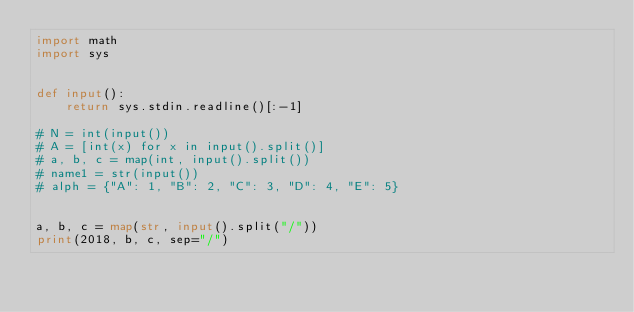Convert code to text. <code><loc_0><loc_0><loc_500><loc_500><_Python_>import math
import sys


def input():
    return sys.stdin.readline()[:-1]

# N = int(input())
# A = [int(x) for x in input().split()]
# a, b, c = map(int, input().split())
# name1 = str(input())
# alph = {"A": 1, "B": 2, "C": 3, "D": 4, "E": 5}


a, b, c = map(str, input().split("/"))
print(2018, b, c, sep="/")
</code> 